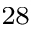<formula> <loc_0><loc_0><loc_500><loc_500>^ { 2 8 }</formula> 